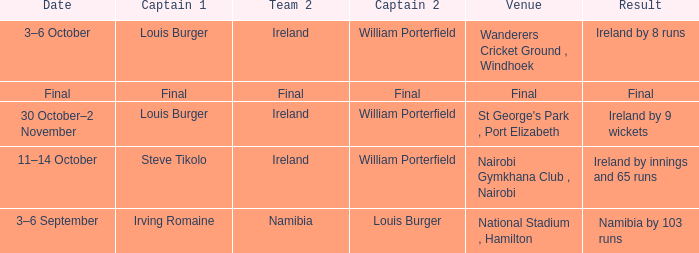Which Captain 2 has a Result of ireland by 8 runs? William Porterfield. 